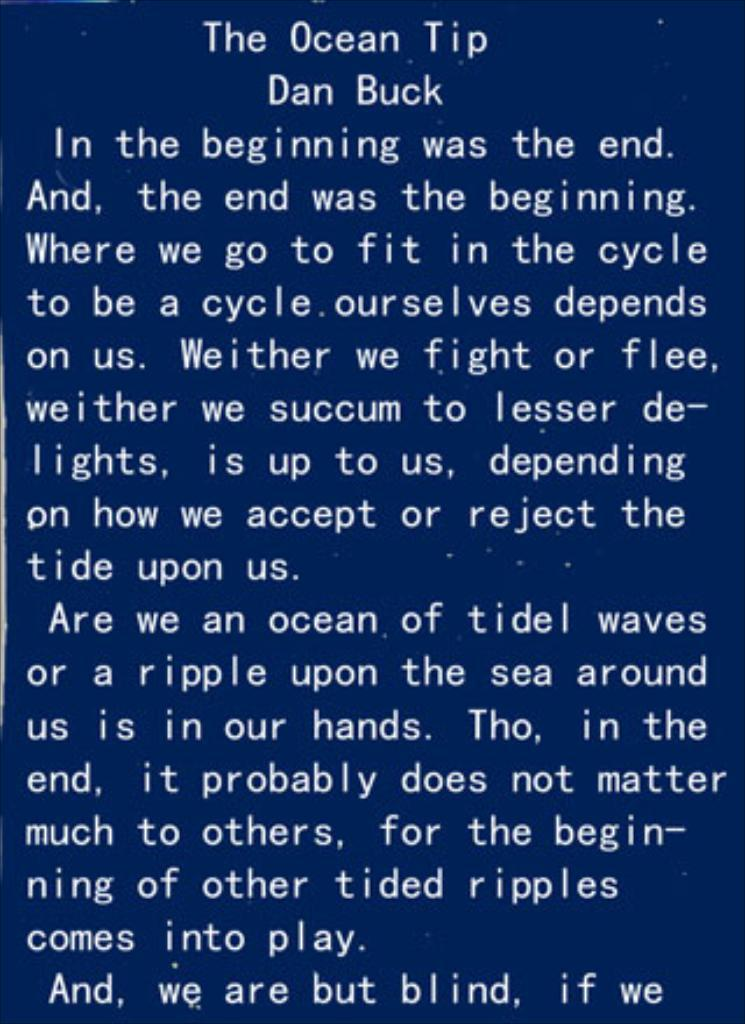Provide a one-sentence caption for the provided image. White text with a blue background which is titled,"The Ocean Tip" by Dan Buck. 